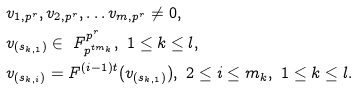Convert formula to latex. <formula><loc_0><loc_0><loc_500><loc_500>& v _ { 1 , p ^ { r } } , v _ { 2 , p ^ { r } } , \dots v _ { m , p ^ { r } } \not = 0 , \\ & v _ { ( s _ { k , 1 } ) } \in \ F _ { p ^ { t m _ { k } } } ^ { p ^ { r } } , \ 1 \leq k \leq l , \\ & v _ { ( s _ { k , i } ) } = F ^ { ( i - 1 ) t } ( v _ { ( s _ { k , 1 } ) } ) , \ 2 \leq i \leq m _ { k } , \ 1 \leq k \leq l .</formula> 